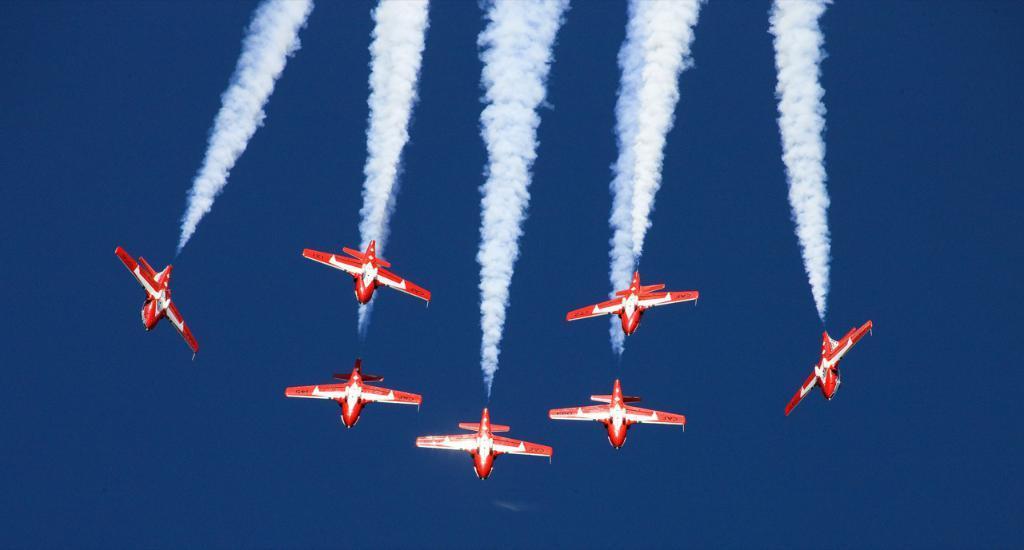Can you describe this image briefly? This picture consists of few red color aircraft flying in the sky by emitting the smoke. 